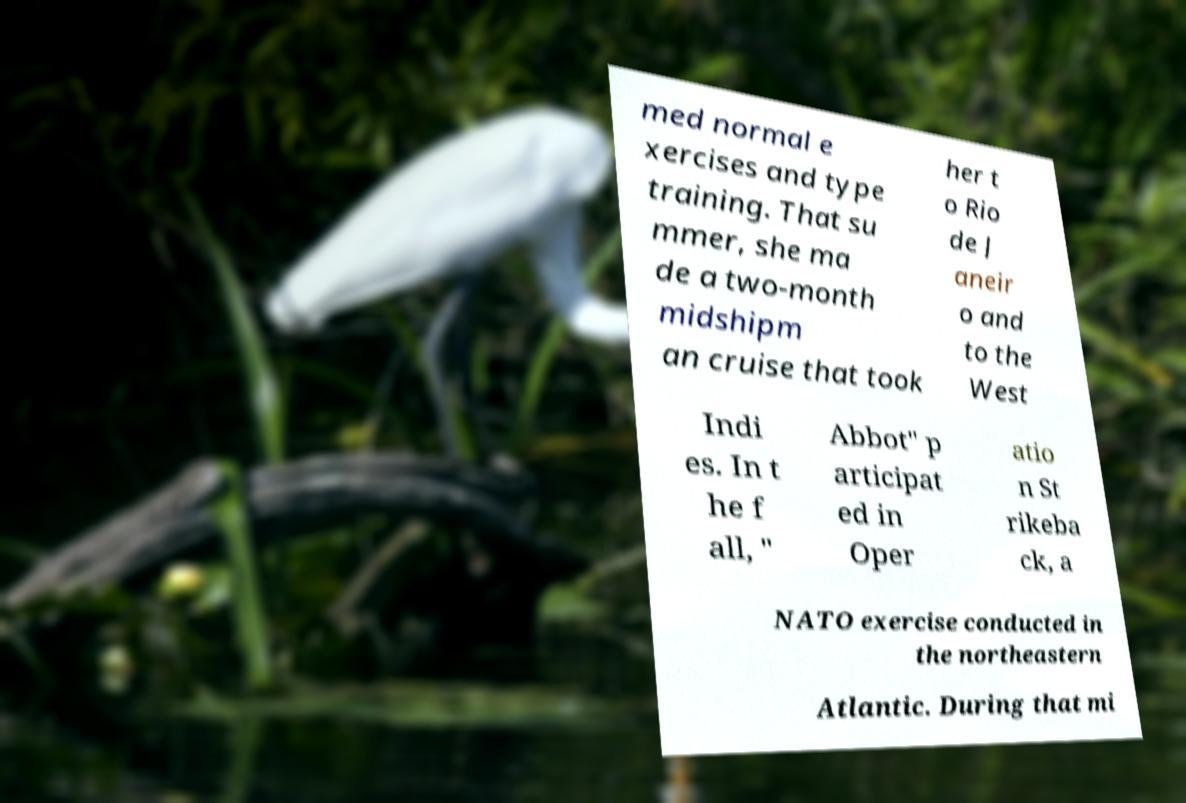Please read and relay the text visible in this image. What does it say? med normal e xercises and type training. That su mmer, she ma de a two-month midshipm an cruise that took her t o Rio de J aneir o and to the West Indi es. In t he f all, " Abbot" p articipat ed in Oper atio n St rikeba ck, a NATO exercise conducted in the northeastern Atlantic. During that mi 